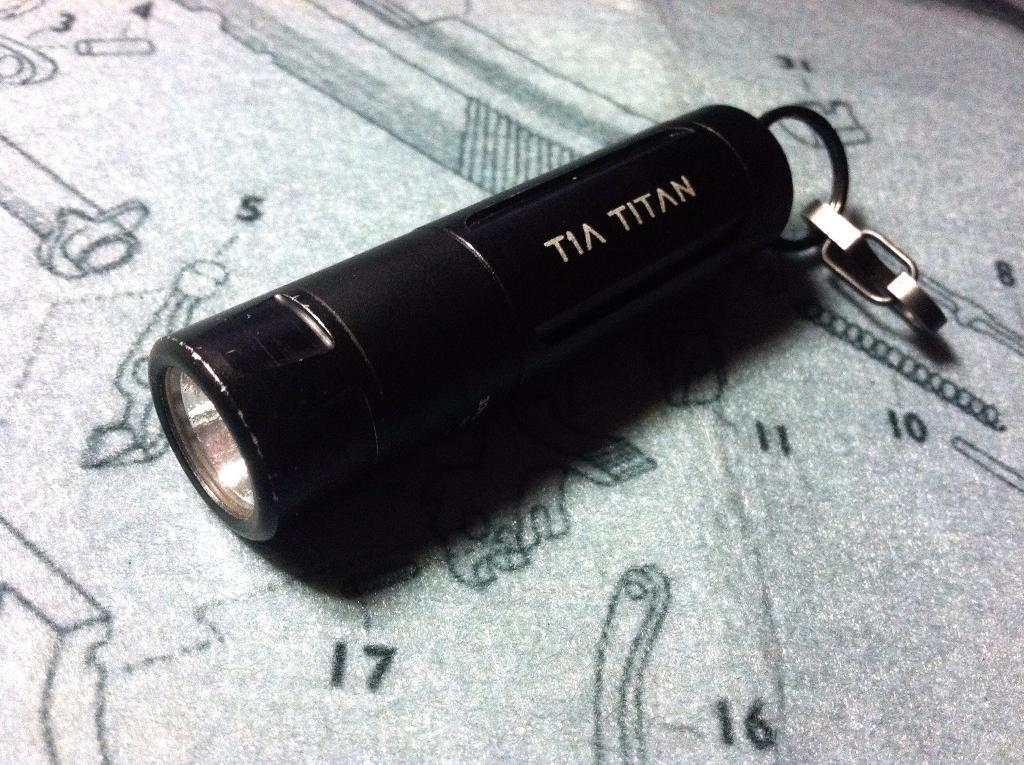What object is the main focus of the image? There is a torch light in the image. Can you describe any other elements in the background of the image? There are numbers visible on a surface in the background of the image. What type of butter is being used to lubricate the rifle in the image? There is no butter or rifle present in the image; it only features a torch light and numbers on a surface. 